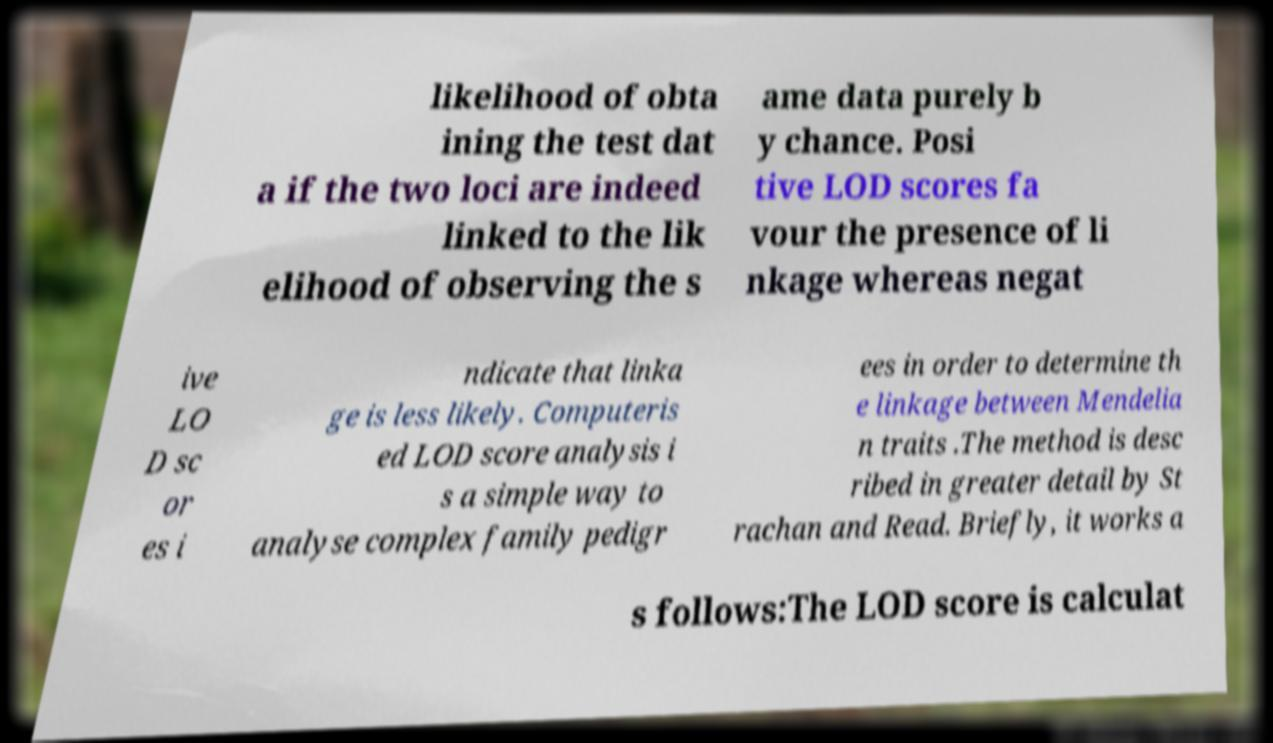Please identify and transcribe the text found in this image. likelihood of obta ining the test dat a if the two loci are indeed linked to the lik elihood of observing the s ame data purely b y chance. Posi tive LOD scores fa vour the presence of li nkage whereas negat ive LO D sc or es i ndicate that linka ge is less likely. Computeris ed LOD score analysis i s a simple way to analyse complex family pedigr ees in order to determine th e linkage between Mendelia n traits .The method is desc ribed in greater detail by St rachan and Read. Briefly, it works a s follows:The LOD score is calculat 